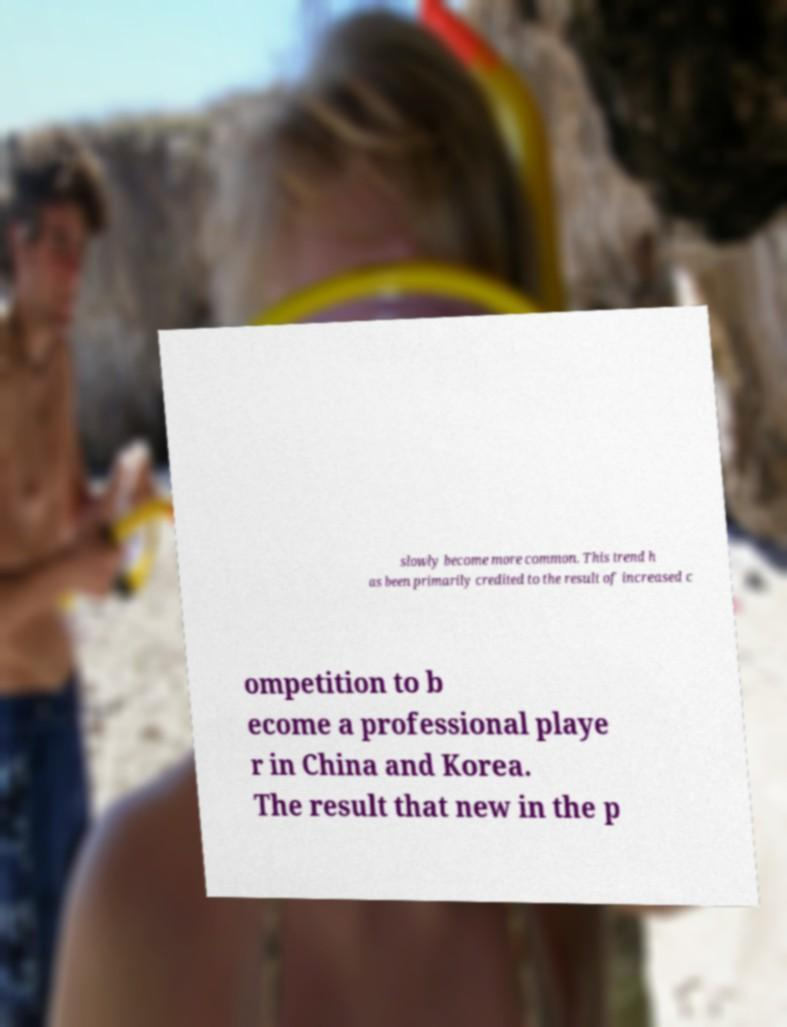Please read and relay the text visible in this image. What does it say? slowly become more common. This trend h as been primarily credited to the result of increased c ompetition to b ecome a professional playe r in China and Korea. The result that new in the p 